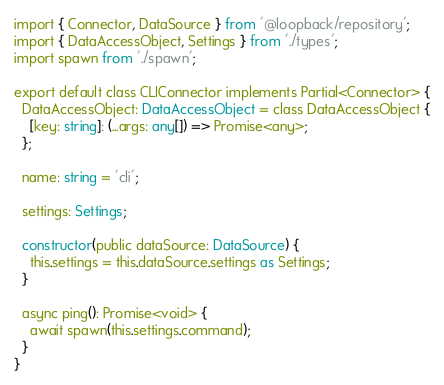Convert code to text. <code><loc_0><loc_0><loc_500><loc_500><_TypeScript_>import { Connector, DataSource } from '@loopback/repository';
import { DataAccessObject, Settings } from './types';
import spawn from './spawn';

export default class CLIConnector implements Partial<Connector> {
  DataAccessObject: DataAccessObject = class DataAccessObject {
    [key: string]: (...args: any[]) => Promise<any>;
  };

  name: string = 'cli';

  settings: Settings;

  constructor(public dataSource: DataSource) {
    this.settings = this.dataSource.settings as Settings;
  }

  async ping(): Promise<void> {
    await spawn(this.settings.command);
  }
}
</code> 